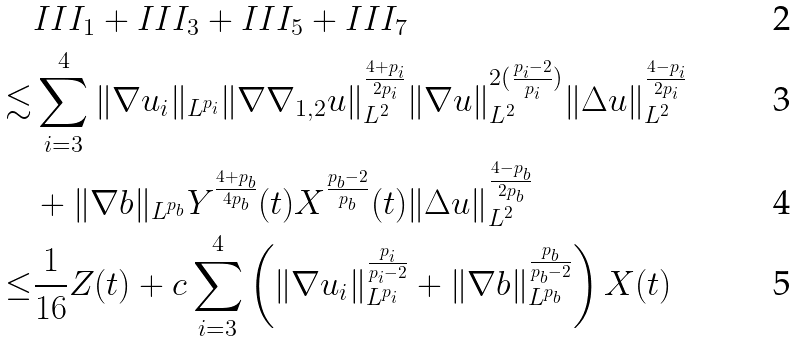<formula> <loc_0><loc_0><loc_500><loc_500>& I I I _ { 1 } + I I I _ { 3 } + I I I _ { 5 } + I I I _ { 7 } \\ \lesssim & \sum _ { i = 3 } ^ { 4 } \| \nabla u _ { i } \| _ { L ^ { p _ { i } } } \| \nabla \nabla _ { 1 , 2 } u \| _ { L ^ { 2 } } ^ { \frac { 4 + p _ { i } } { 2 p _ { i } } } \| \nabla u \| _ { L ^ { 2 } } ^ { 2 ( \frac { p _ { i } - 2 } { p _ { i } } ) } \| \Delta u \| _ { L ^ { 2 } } ^ { \frac { 4 - p _ { i } } { 2 p _ { i } } } \\ & + \| \nabla b \| _ { L ^ { p _ { b } } } Y ^ { \frac { 4 + p _ { b } } { 4 p _ { b } } } ( t ) X ^ { \frac { p _ { b } - 2 } { p _ { b } } } ( t ) \| \Delta u \| _ { L ^ { 2 } } ^ { \frac { 4 - p _ { b } } { 2 p _ { b } } } \\ \leq & \frac { 1 } { 1 6 } Z ( t ) + c \sum _ { i = 3 } ^ { 4 } \left ( \| \nabla u _ { i } \| _ { L ^ { p _ { i } } } ^ { \frac { p _ { i } } { p _ { i } - 2 } } + \| \nabla b \| _ { L ^ { p _ { b } } } ^ { \frac { p _ { b } } { p _ { b } - 2 } } \right ) X ( t )</formula> 